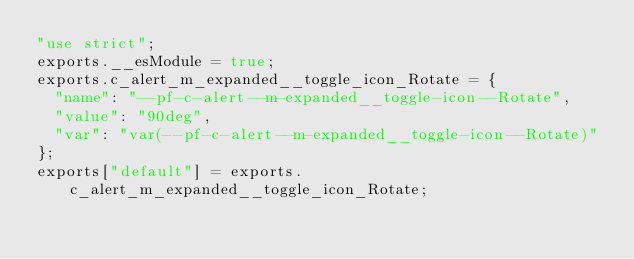<code> <loc_0><loc_0><loc_500><loc_500><_JavaScript_>"use strict";
exports.__esModule = true;
exports.c_alert_m_expanded__toggle_icon_Rotate = {
  "name": "--pf-c-alert--m-expanded__toggle-icon--Rotate",
  "value": "90deg",
  "var": "var(--pf-c-alert--m-expanded__toggle-icon--Rotate)"
};
exports["default"] = exports.c_alert_m_expanded__toggle_icon_Rotate;</code> 